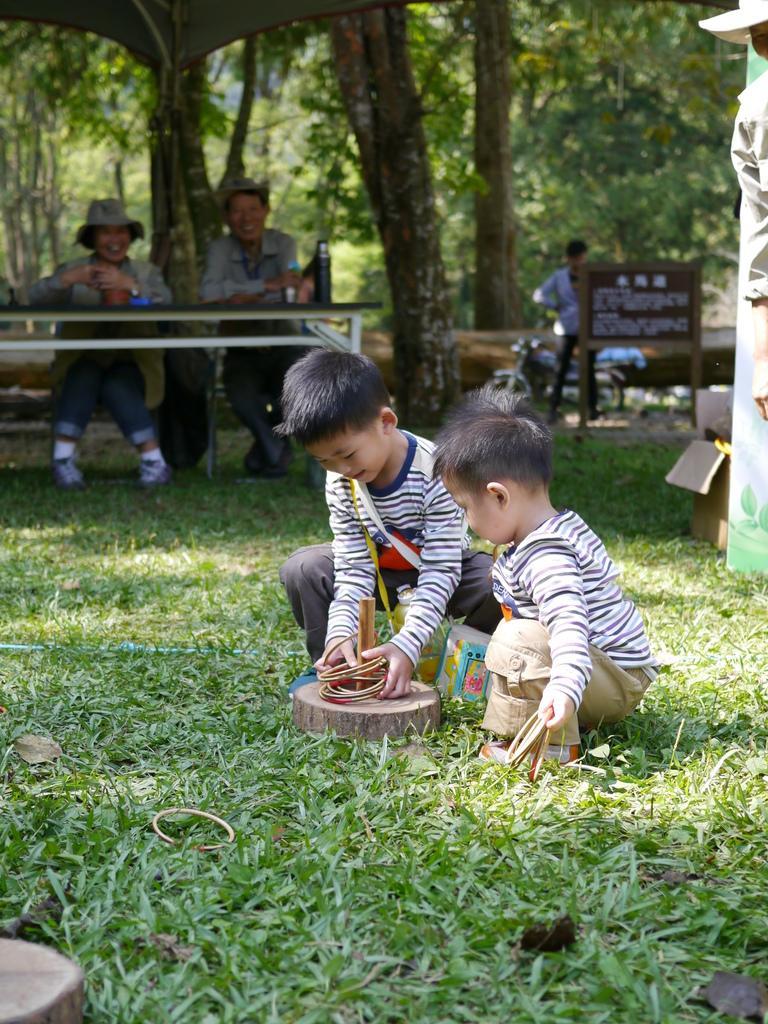How would you summarize this image in a sentence or two? In the picture I can see people, among them two kids are crouching on the ground. In the background I can see the grass, trees, a board and some other things. The background of the image is blurred. 